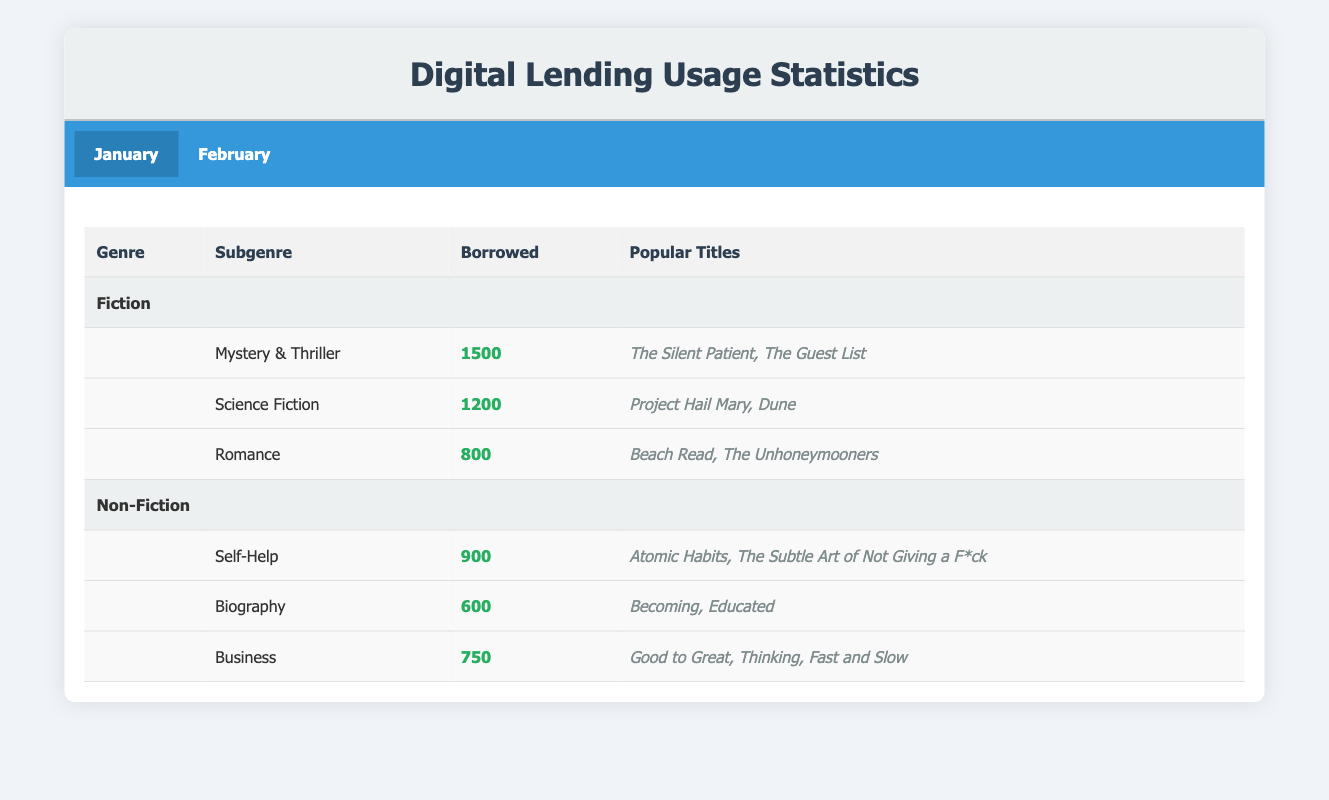What genre had the highest borrowing in January? In January, the numbers of books borrowed by genre are: Fiction has 3000 (1500+1200+800) and Non-Fiction has 2250 (900+600+750). Fiction is the higher of the two.
Answer: Fiction How many books were borrowed in the Mystery & Thriller subgenre in February? In February, the table indicates that the Mystery & Thriller subgenre had 1700 books borrowed.
Answer: 1700 What is the total number of books borrowed from Romance genre across both months? For January, 800 were borrowed in Romance and for February, 900 were borrowed. Summing these gives: 800 + 900 = 1700.
Answer: 1700 Did more books get borrowed in Non-Fiction than in Fiction in February? In February, 2700 books were borrowed in Fiction (1700 + 1100 + 900) and 2200 in Non-Fiction (950 + 650 + 600). 2700 is greater than 2200.
Answer: Yes What subgenre had the most borrowing in January, and how many books were borrowed? Reviewing the numbers in January, the subgenre with the most borrowings was Mystery & Thriller at 1500.
Answer: Mystery & Thriller, 1500 